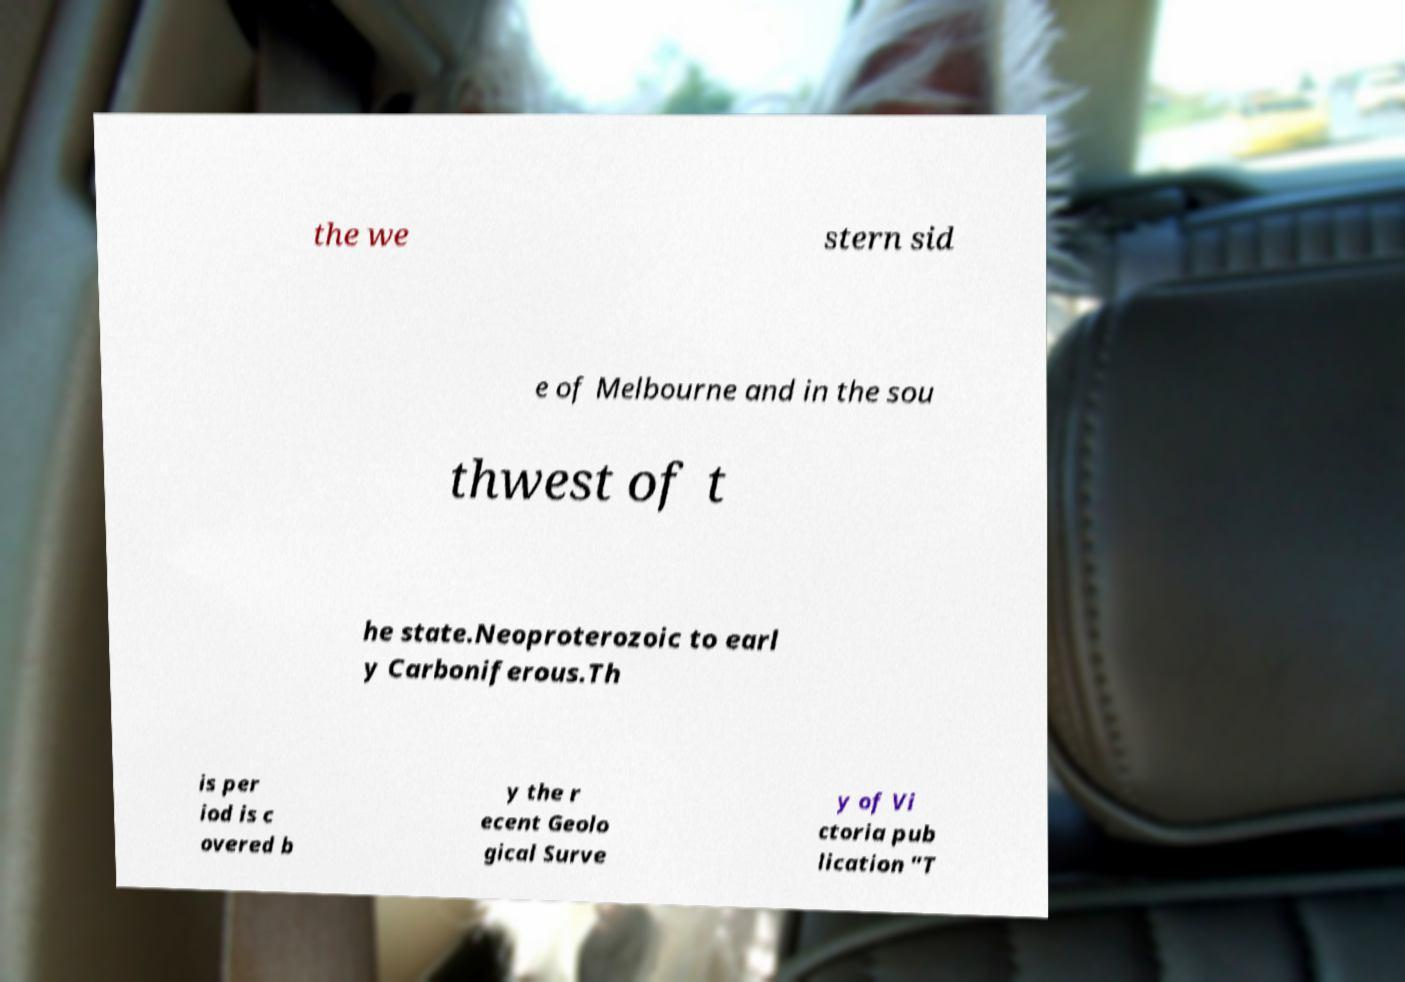Can you read and provide the text displayed in the image?This photo seems to have some interesting text. Can you extract and type it out for me? the we stern sid e of Melbourne and in the sou thwest of t he state.Neoproterozoic to earl y Carboniferous.Th is per iod is c overed b y the r ecent Geolo gical Surve y of Vi ctoria pub lication "T 